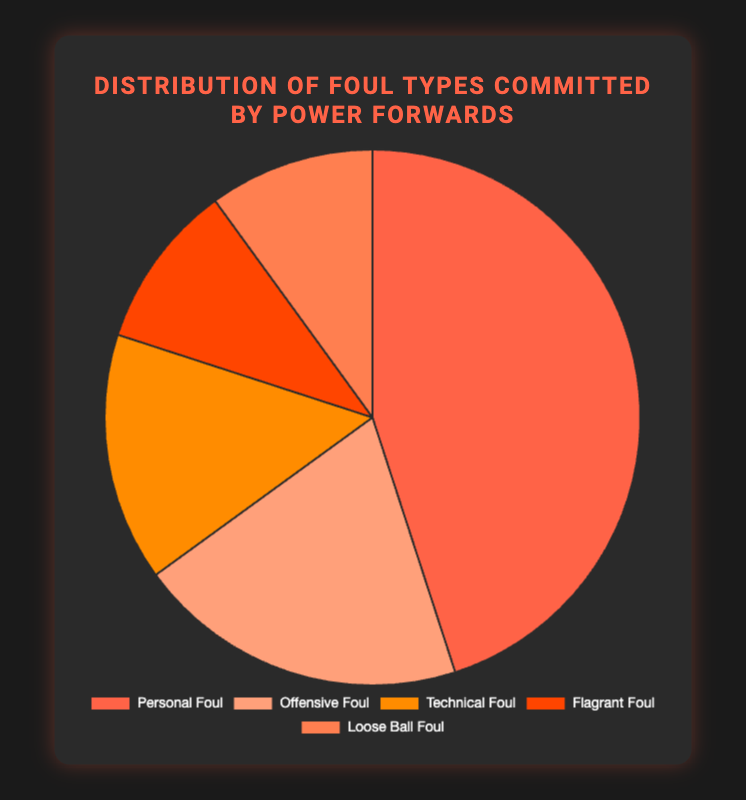What percentage of fouls committed are either technical or flagrant fouls? To find the percentage of fouls that are either technical or flagrant, we need to sum the percentages for these two foul types. The percentage for technical fouls is 15% and for flagrant fouls is 10%. Adding these together: 15% + 10% = 25%
Answer: 25% Which type of foul is the least common among power forwards according to the chart? We find the smallest percentage value among the given data points: Personal Foul (45%), Offensive Foul (20%), Technical Foul (15%), Flagrant Foul (10%), Loose Ball Foul (10%). Both Flagrant Foul and Loose Ball Foul have the smallest percentage at 10%.
Answer: Flagrant Foul, Loose Ball Foul How many types of fouls have a percentage above 10%? We count the foul types with percentages greater than 10%: Personal Foul (45%), Offensive Foul (20%), and Technical Foul (15%). There are three foul types with percentages above 10%.
Answer: 3 What is the most common foul type committed? The foul type with the highest percentage is identified: Personal Foul has the highest percentage at 45%.
Answer: Personal Foul Compare the percentage of personal fouls to offensive fouls. Which is higher and by how much? The percentage for personal fouls is 45% and for offensive fouls is 20%. Subtracting the offensive foul percentage from the personal foul percentage gives 45% - 20% = 25%. Personal Fouls are higher by 25%.
Answer: Personal Foul by 25% What is the sum of the percentages for fouls that are not personal fouls? Add the percentages for all foul types other than Personal Foul: Offensive Foul (20%) + Technical Foul (15%) + Flagrant Foul (10%) + Loose Ball Foul (10%) = 55%
Answer: 55% What is the difference in percentage between technical and loose ball fouls? The percentage for technical fouls is 15% and for loose ball fouls is 10%. The difference is calculated as 15% - 10% = 5%.
Answer: 5% Which foul type makes up a fifth of the total fouls committed? A fifth of the total fouls (100%) is 20%. Checking the percentages: Offensive Foul has a percentage that exactly matches this fraction (20%).
Answer: Offensive Foul What proportion of the fouls are flagrant or loose ball fouls combined compared to personal fouls? Flagrant Foul (10%) + Loose Ball Foul (10%) = 20%. Personal Foul is 45%. Dividing the combined percentage by the personal foul percentage gives 20% / 45% ≈ 0.44
Answer: 0.44 